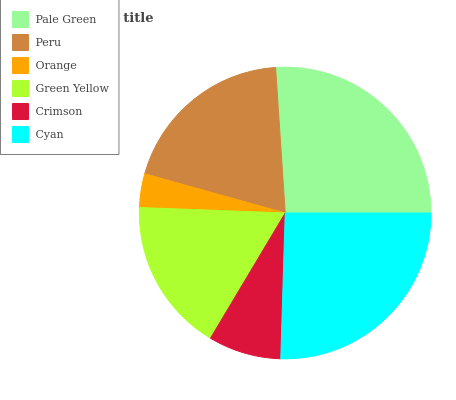Is Orange the minimum?
Answer yes or no. Yes. Is Pale Green the maximum?
Answer yes or no. Yes. Is Peru the minimum?
Answer yes or no. No. Is Peru the maximum?
Answer yes or no. No. Is Pale Green greater than Peru?
Answer yes or no. Yes. Is Peru less than Pale Green?
Answer yes or no. Yes. Is Peru greater than Pale Green?
Answer yes or no. No. Is Pale Green less than Peru?
Answer yes or no. No. Is Peru the high median?
Answer yes or no. Yes. Is Green Yellow the low median?
Answer yes or no. Yes. Is Pale Green the high median?
Answer yes or no. No. Is Crimson the low median?
Answer yes or no. No. 